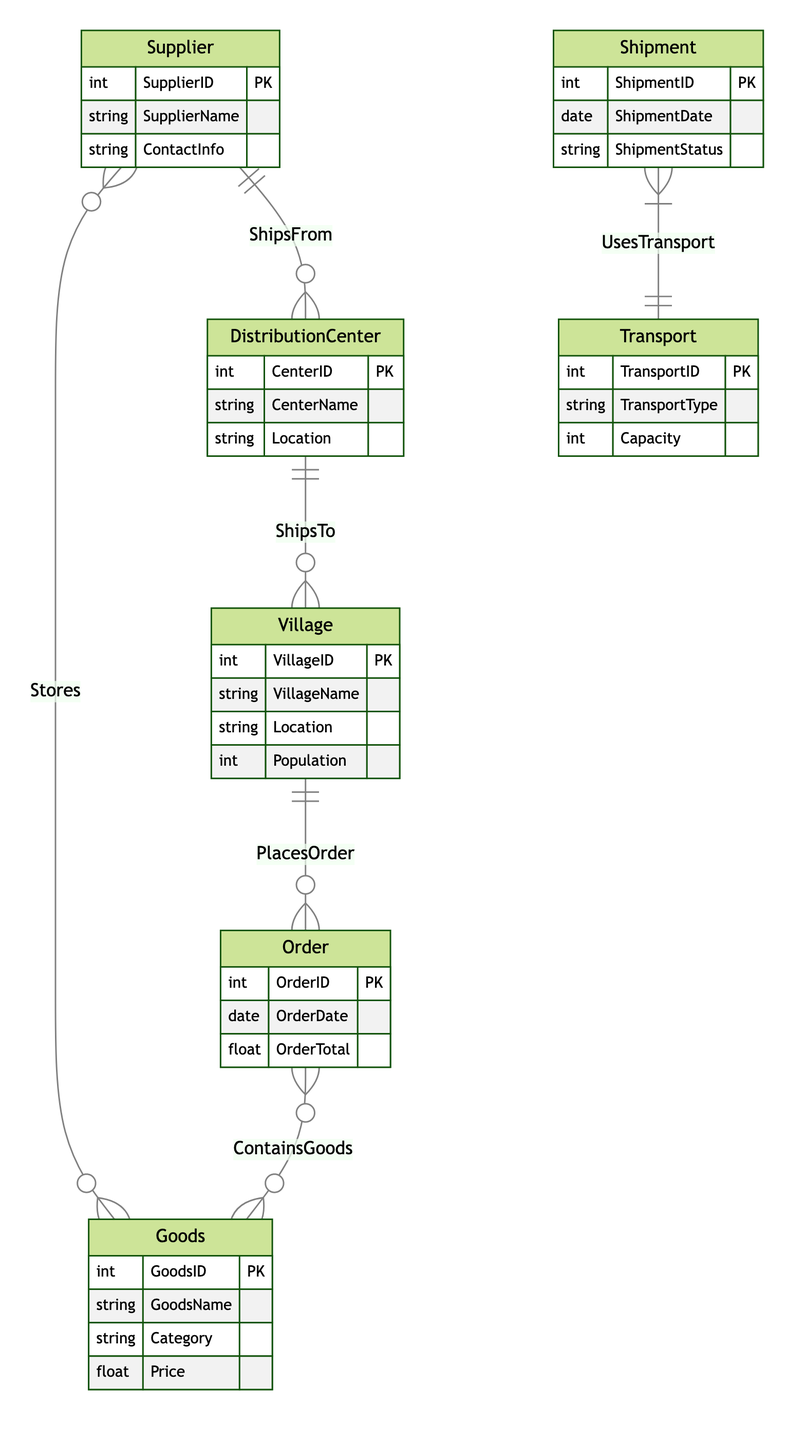What entities are involved in the distribution network? The diagram lists six entities: Village, Goods, Supplier, DistributionCenter, Shipment, Order, and Transport. These represent the various components involved in the goods distribution process.
Answer: Village, Goods, Supplier, DistributionCenter, Shipment, Order, Transport How many relationships are depicted in the diagram? There are six relationships connecting the entities: PlacesOrder, ContainsGoods, ShipsTo, Stores, ShipsFrom, and UsesTransport. Each relationship describes how two entities interact with one another within the distribution network.
Answer: Six What attribute identifies a Village? The VillageID attribute uniquely identifies each village in the diagram, allowing for distinction between different villages in the goods distribution network.
Answer: VillageID Which entity has a ShipmentStatus attribute? The Shipment entity has a ShipmentStatus attribute, which indicates the current status of the shipment in relation to the distribution and delivery of goods.
Answer: Shipment How many attributes does the Goods entity have? The Goods entity has four attributes: GoodsID, GoodsName, Category, and Price, which capture essential details about goods available in the distribution network.
Answer: Four What is the relationship between Supplier and Goods? The relationship is called Stores, indicating that suppliers store goods within the network, linking suppliers directly to the types of goods they offer.
Answer: Stores Which relationship connects DistributionCenter and Village? The relationship is called ShipsTo, showing that distribution centers are responsible for shipping goods to the villages, forming an essential part of the distribution network.
Answer: ShipsTo What attribute represents the quantity of goods ordered? The Quantity attribute within the ContainsGoods relationship represents how many units of goods are included in an order made by a village.
Answer: Quantity Who handles transportation of shipments? The Transport entity, specifically through the UsesTransport relationship with Shipment, handles the transportation logistics for shipments within the distribution network.
Answer: Transport 